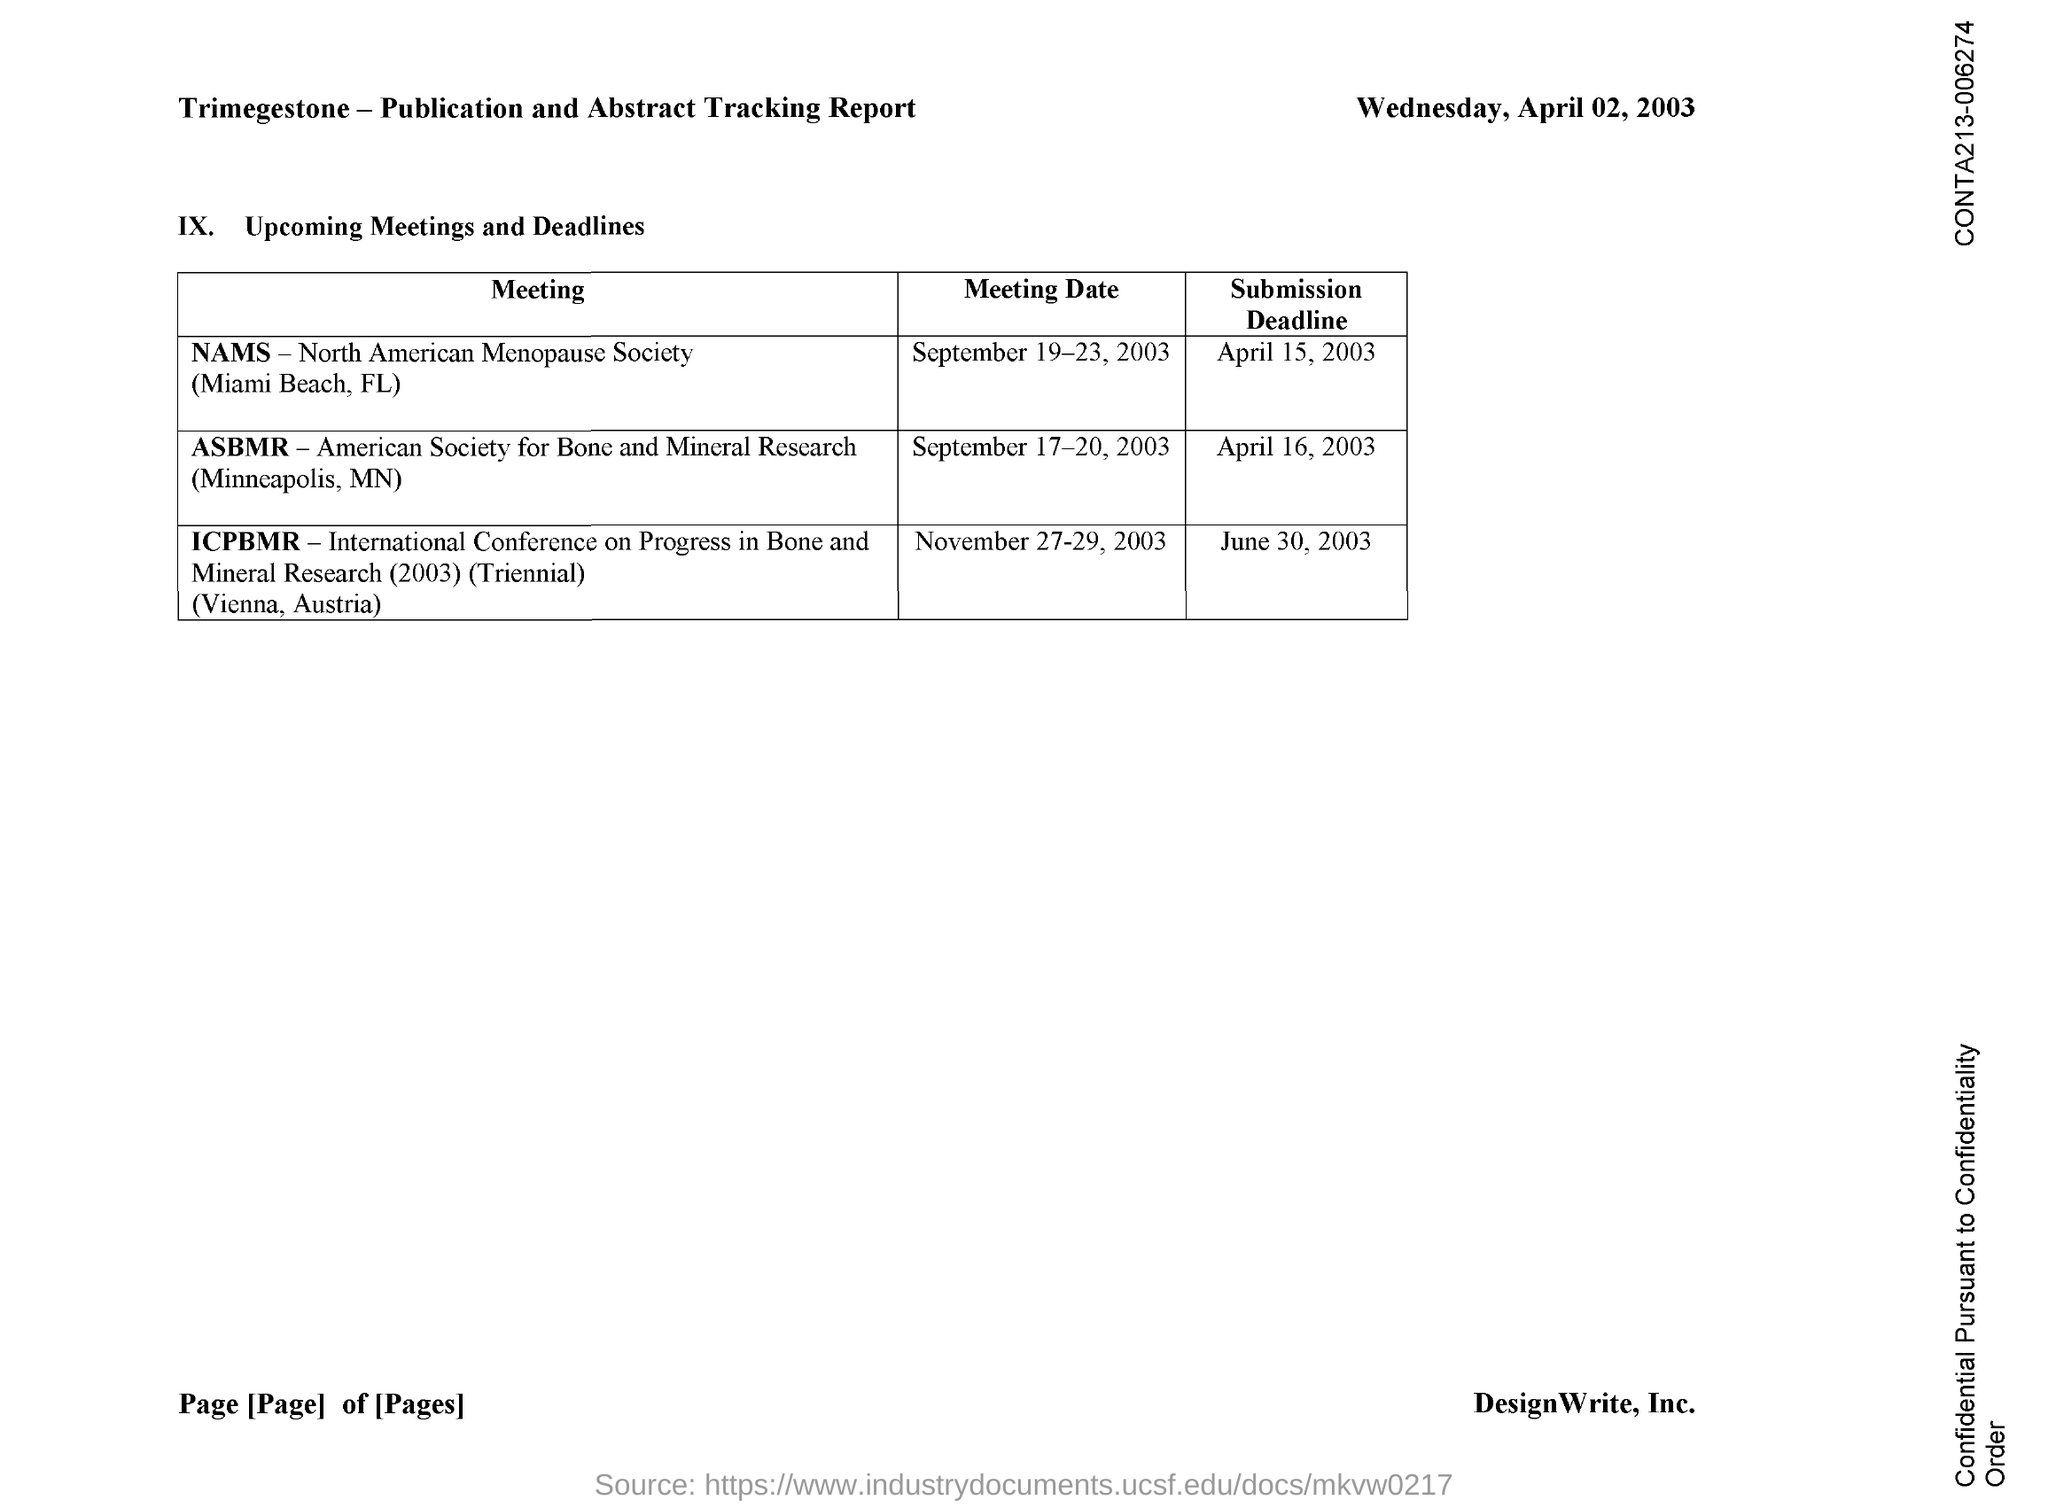Give some essential details in this illustration. The full form of ASBMR is the American Society for Bone and Mineral Research. The NAMS meeting was conducted on the date of September 19-23, 2003. The ICPBMR meeting was conducted on November 27-29, 2003. The submission deadline date for the ICPBMR meeting is June 30, 2003. The submission deadline date for the ASBMR meeting is April 16, 2003. 